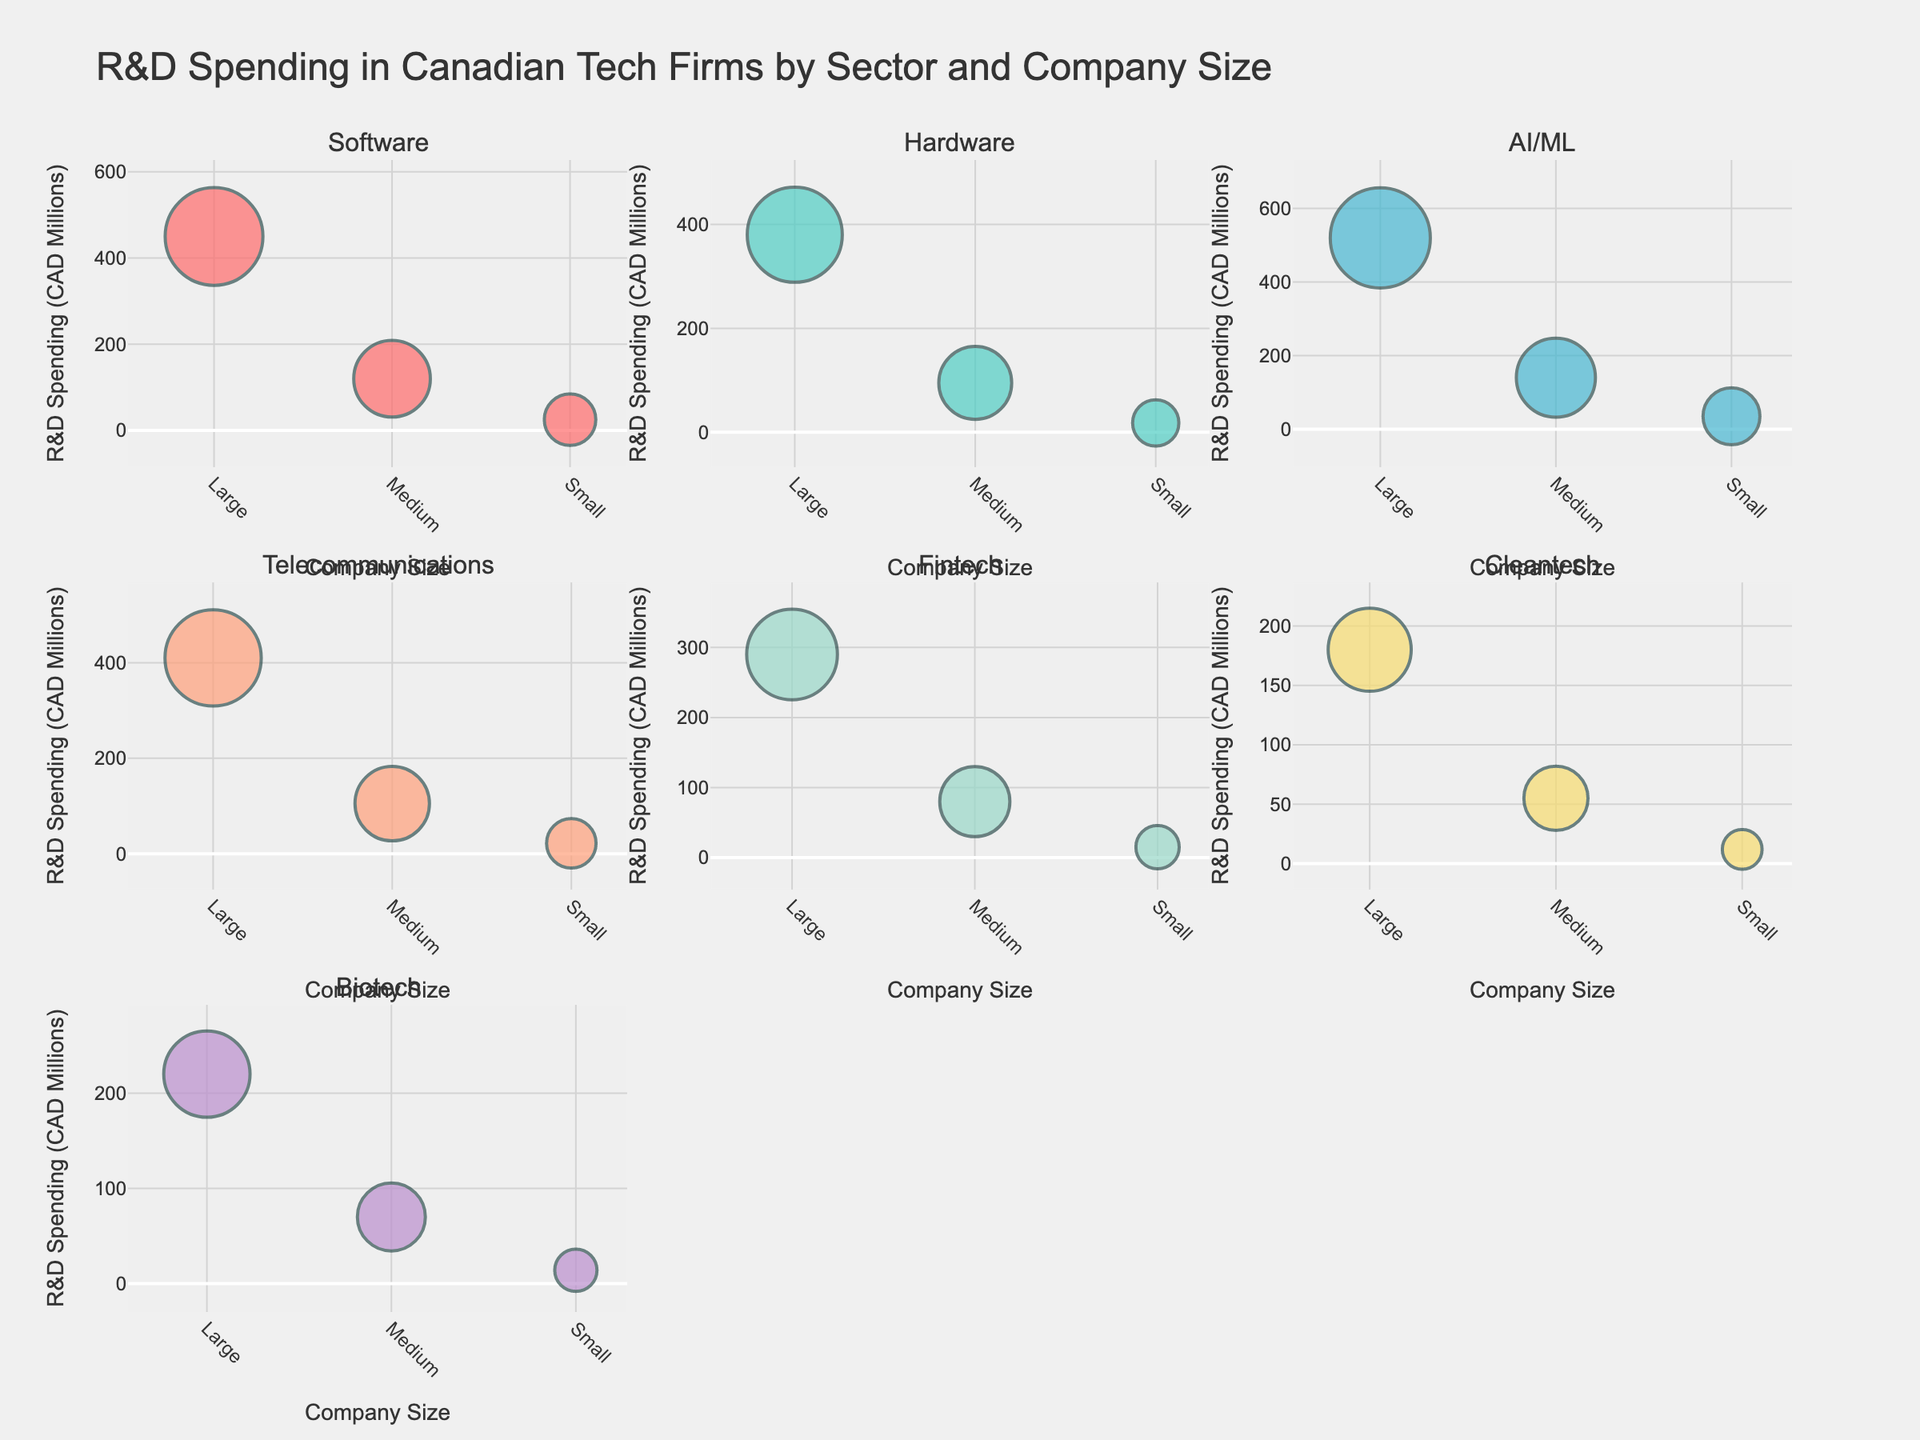what is the total R&D spending of large companies in the Telecommunications sector? From the figure, note the R&D spending of large companies in the Telecommunications sector, which is $410 million. Thus, the total is just this amount since there is only one data point for large companies in that sector.
Answer: 410 million CAD which sector has the highest R&D spending for small companies? By examining the subplot for each sector and assessing the y-values for small companies, AI/ML has the highest R&D spending for small companies at $35 million CAD.
Answer: AI/ML What is the average R&D spending for medium companies across all sectors? Calculate the average for medium companies by summing all R&D spending amounts for them across all sectors and then dividing by the number of sectors (210 in Software + 95 in Hardware + 140 in AI/ML + 105 in Telecommunications + 80 in Fintech + 55 in Cleantech + 70 in Biotech). The total sum is 770, and there are 7 sectors. So, the average is 770 / 7 ≈ 110 million CAD.
Answer: 110 million CAD Which sector shows the highest overall R&D spending? To determine the highest overall R&D spending, sum the CAD across all company sizes within each sector. For instance, in the AI/ML sector, the total R&D is 520 + 140 + 35 = 695 million CAD. Comparing all sectors similarly, the AI/ML sector has the highest with 695 million CAD.
Answer: AI/ML How does the R&D spending between medium and small companies in the Fintech sector compare? By observing both medium and small companies in the Fintech sector, medium companies spend $80 million CAD while small companies spend $15 million CAD. So medium companies spend more.
Answer: Medium spending is higher Which sector has the most considerable variation in R&D spending among different company sizes? Variation can be noted by observing the difference in heights (spending amounts) between large, medium, and small companies within a sector. The AI/ML sector shows considerable variation, with $520 million CAD for large, $140 million CAD for medium, and $35 million CAD for small companies.
Answer: AI/ML How many subplots can be seen in the figure? Count the number of unique sectors (subplot titles) visible in the array of scatterplots. As each sector is represented as a subplot, and there are 7 unique sectors, there are 7 subplots.
Answer: 7 